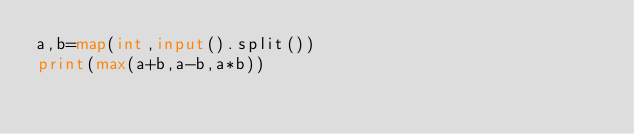Convert code to text. <code><loc_0><loc_0><loc_500><loc_500><_Python_>a,b=map(int,input().split())
print(max(a+b,a-b,a*b))</code> 